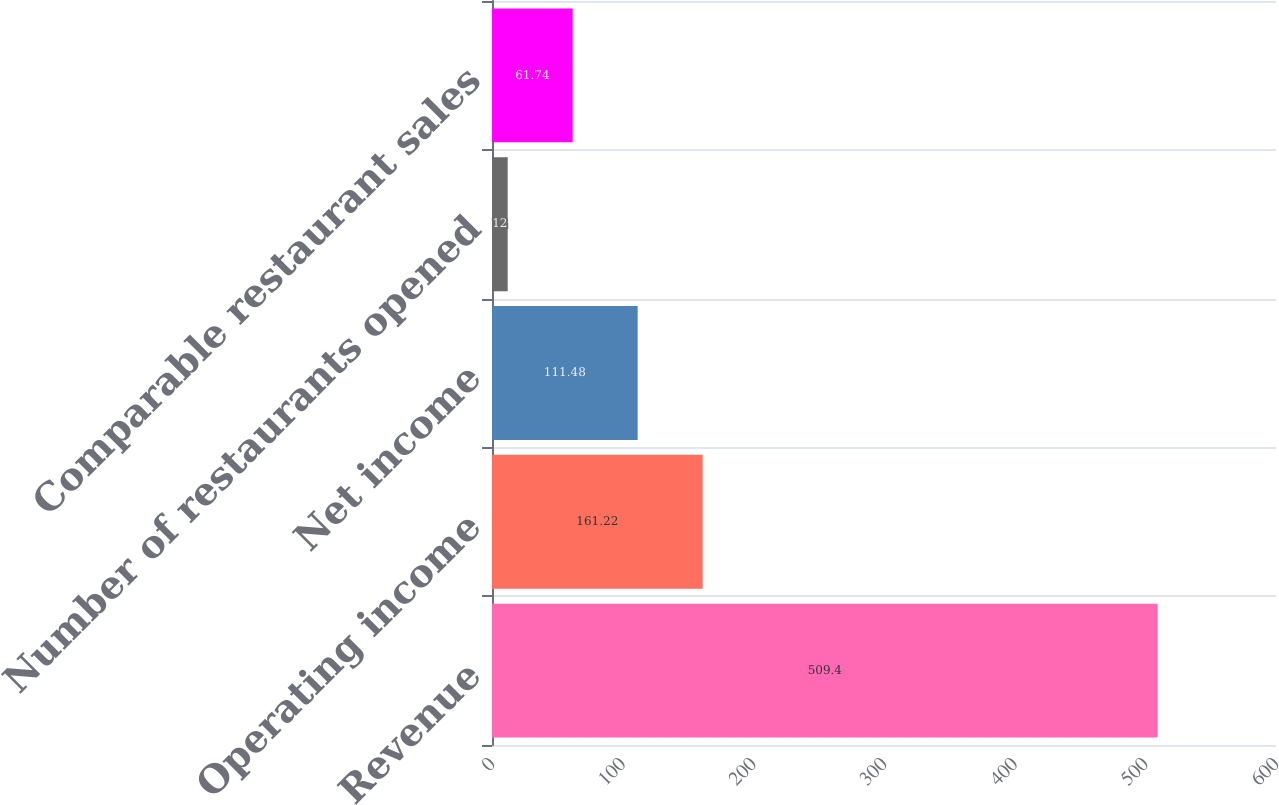Convert chart to OTSL. <chart><loc_0><loc_0><loc_500><loc_500><bar_chart><fcel>Revenue<fcel>Operating income<fcel>Net income<fcel>Number of restaurants opened<fcel>Comparable restaurant sales<nl><fcel>509.4<fcel>161.22<fcel>111.48<fcel>12<fcel>61.74<nl></chart> 